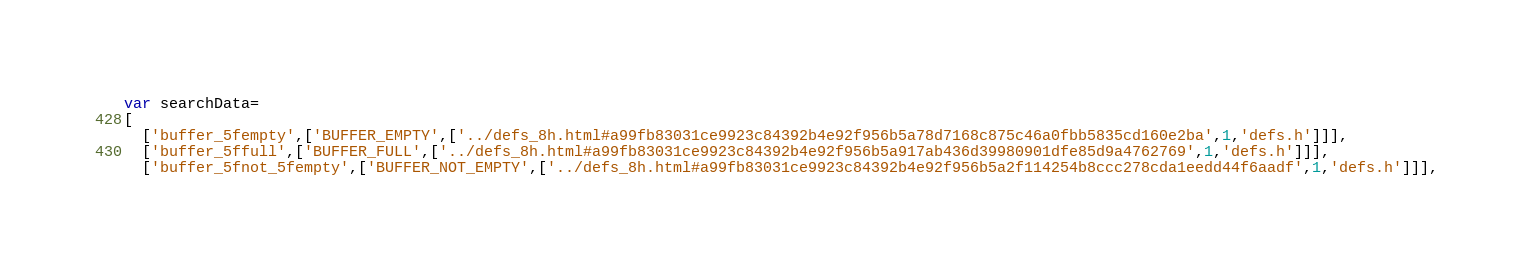<code> <loc_0><loc_0><loc_500><loc_500><_JavaScript_>var searchData=
[
  ['buffer_5fempty',['BUFFER_EMPTY',['../defs_8h.html#a99fb83031ce9923c84392b4e92f956b5a78d7168c875c46a0fbb5835cd160e2ba',1,'defs.h']]],
  ['buffer_5ffull',['BUFFER_FULL',['../defs_8h.html#a99fb83031ce9923c84392b4e92f956b5a917ab436d39980901dfe85d9a4762769',1,'defs.h']]],
  ['buffer_5fnot_5fempty',['BUFFER_NOT_EMPTY',['../defs_8h.html#a99fb83031ce9923c84392b4e92f956b5a2f114254b8ccc278cda1eedd44f6aadf',1,'defs.h']]],</code> 